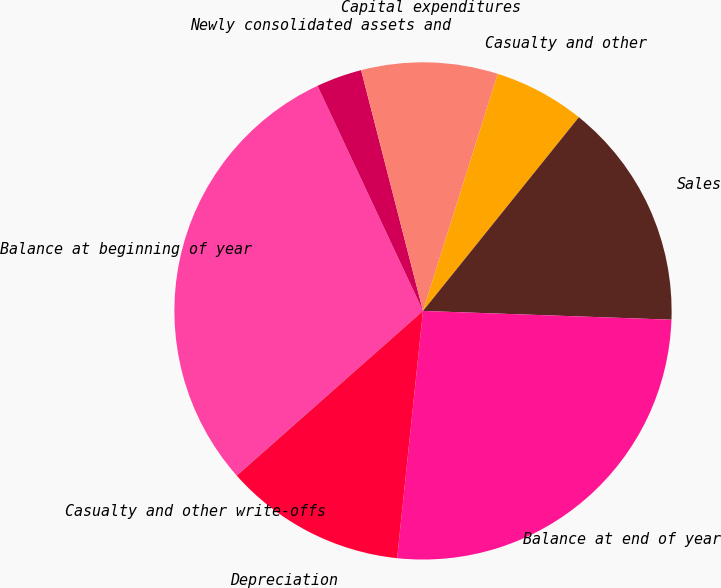<chart> <loc_0><loc_0><loc_500><loc_500><pie_chart><fcel>Balance at beginning of year<fcel>Newly consolidated assets and<fcel>Capital expenditures<fcel>Casualty and other<fcel>Sales<fcel>Balance at end of year<fcel>Depreciation<fcel>Casualty and other write-offs<nl><fcel>29.54%<fcel>2.97%<fcel>8.87%<fcel>5.92%<fcel>14.78%<fcel>26.1%<fcel>11.82%<fcel>0.01%<nl></chart> 